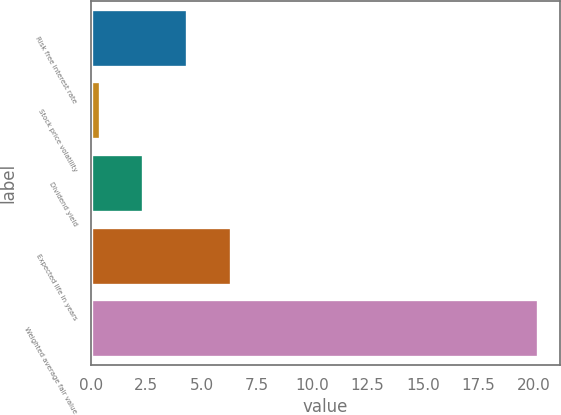Convert chart. <chart><loc_0><loc_0><loc_500><loc_500><bar_chart><fcel>Risk free interest rate<fcel>Stock price volatility<fcel>Dividend yield<fcel>Expected life in years<fcel>Weighted average fair value<nl><fcel>4.35<fcel>0.39<fcel>2.37<fcel>6.33<fcel>20.18<nl></chart> 